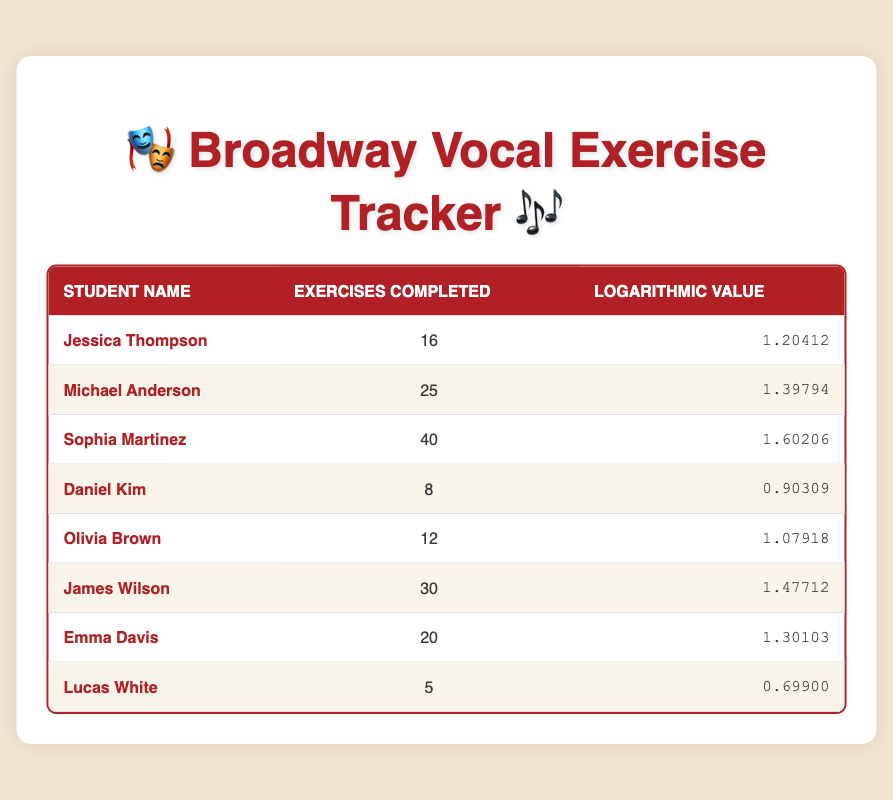What is the highest number of exercises completed by a student? The table lists the number of exercises completed by each student. Scanning through the data, Sophia Martinez has completed the highest number with 40 exercises.
Answer: 40 How many students completed more than 15 exercises? To find the number of students who completed more than 15 exercises, we can check each student's count: Michael Anderson (25), Sophia Martinez (40), James Wilson (30), Emma Davis (20), and Jessica Thompson (16), totaling 5 students.
Answer: 5 What is the difference between the exercises completed by the student with the maximum and minimum exercises? The maximum number of exercises is completed by Sophia Martinez with 40, while the minimum is by Lucas White with 5. Calculating the difference gives us 40 - 5 = 35.
Answer: 35 Is it true that Daniel Kim completed more exercises than Olivia Brown? Checking the table, Daniel Kim completed 8 exercises and Olivia Brown completed 12 exercises. Since 8 is not greater than 12, the statement is false.
Answer: No What is the average number of exercises completed by all students? To find the average, sum all completed exercises: 16 + 25 + 40 + 8 + 12 + 30 + 20 + 5 = 156. There are 8 students; hence the average is 156/8 = 19.5.
Answer: 19.5 Which student has a logarithmic value closest to 1.3? Looking through the logarithmic values, Emma Davis has 1.30103, which is closest to 1.3 among all students.
Answer: Emma Davis How many students completed fewer than 10 exercises? From the table, only Lucas White completed 5 exercises, and Daniel Kim completed 8 exercises. Thus, there are 2 students who completed fewer than 10 exercises.
Answer: 2 What is the sum of exercises completed by students who completed more than 20 exercises? The students who completed more than 20 exercises are Sophia Martinez (40), James Wilson (30), and Michael Anderson (25). Adding their completed exercises gives 40 + 30 + 25 = 95.
Answer: 95 Did more students complete 20 or fewer exercises compared to those who completed more than 20? From the table, students with 20 or fewer exercises are Jessica Thompson (16), Daniel Kim (8), Olivia Brown (12), and Lucas White (5), totaling 4 students. Students with more than 20 are Sophia Martinez (40), Michael Anderson (25), and James Wilson (30), totaling 3. Thus, more students completed 20 or fewer exercises.
Answer: Yes 